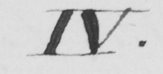Please provide the text content of this handwritten line. IV . 